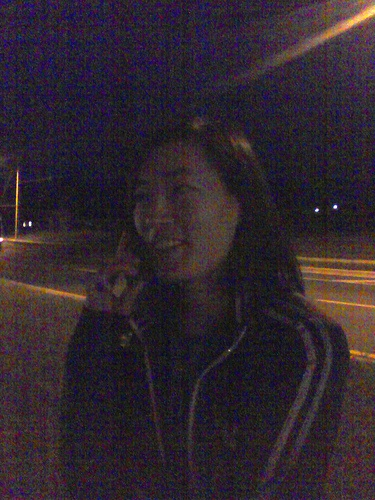Describe the objects in this image and their specific colors. I can see people in navy, black, and maroon tones and cell phone in navy, black, and purple tones in this image. 